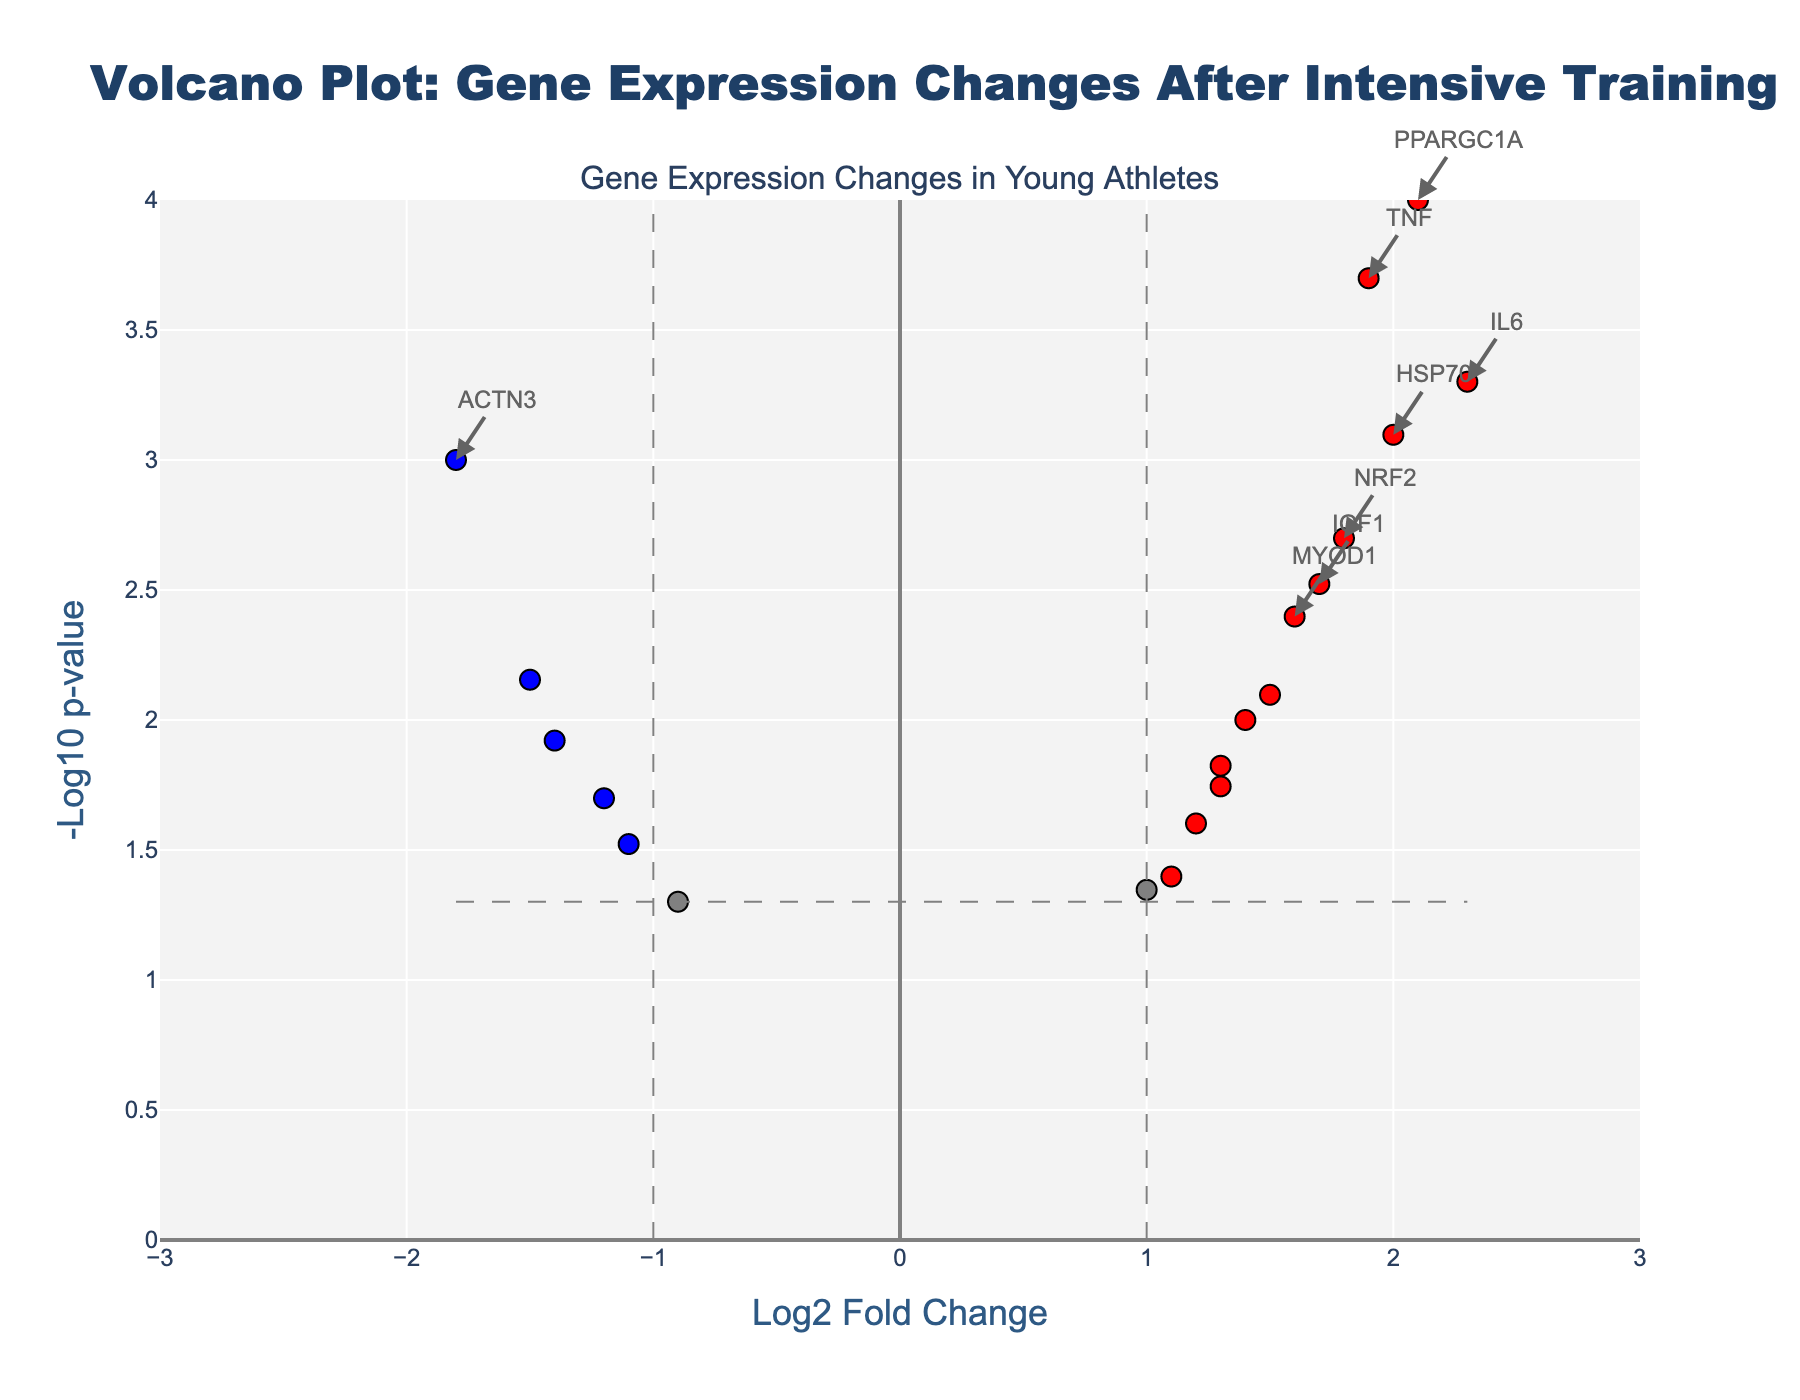which genes are upregulated according to the volcano plot? The upregulated genes are represented by red dots, which indicate a log2 fold change greater than 1 and a p-value less than 0.05. By inspecting these red dots, we can list the genes.
Answer: IL6, IGF1, VEGFA, TNF, PPARGC1A, HIF1A, MYOD1, AMPK, TGFB1, HSP70, NRF2, SOD2, PPAR, NFKB1 what is the threshold for a gene to be considered significantly changed? The figure uses gray dashed lines to indicate the thresholds. Genes with a log2 fold change greater than ±1 and a p-value less than 0.05 are considered significantly changed.
Answer: Log2 fold change greater than ±1 and p-value less than 0.05 how many genes are significantly downregulated? Significantly downregulated genes are represented by blue dots, which have a log2 fold change less than -1 and a p-value less than 0.05. Count the blue dots on the plot to find the number.
Answer: 4 is the gene ACTN3 upregulated or downregulated? Inspect the log2 fold change and color of the dot representing ACTN3. The log2 fold change for ACTN3 is -1.8 and the dot is blue, indicating downregulation.
Answer: Downregulated which gene has the highest log2 fold change and is it upregulated or downregulated? Identify the gene with the highest absolute value of log2 fold change from the x-axis. The log2 fold change for TNF is 2.3, which is the highest. TNF is upregulated because it is red.
Answer: IL6, Upregulated which gene has the lowest p-value? Look at the y-axis to find the gene with the tallest corresponding dot, which means the highest -log10 p-value. The gene with the lowest p-value will have the highest point.
Answer: PPARGC1A 